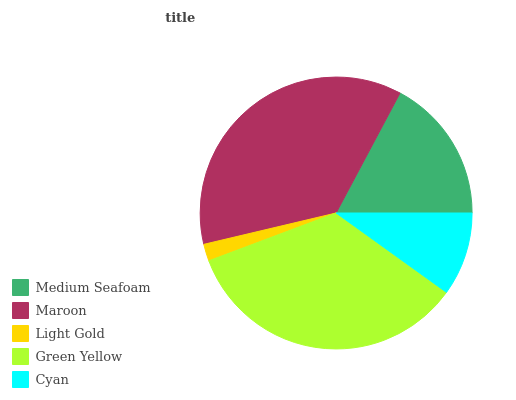Is Light Gold the minimum?
Answer yes or no. Yes. Is Maroon the maximum?
Answer yes or no. Yes. Is Maroon the minimum?
Answer yes or no. No. Is Light Gold the maximum?
Answer yes or no. No. Is Maroon greater than Light Gold?
Answer yes or no. Yes. Is Light Gold less than Maroon?
Answer yes or no. Yes. Is Light Gold greater than Maroon?
Answer yes or no. No. Is Maroon less than Light Gold?
Answer yes or no. No. Is Medium Seafoam the high median?
Answer yes or no. Yes. Is Medium Seafoam the low median?
Answer yes or no. Yes. Is Maroon the high median?
Answer yes or no. No. Is Maroon the low median?
Answer yes or no. No. 